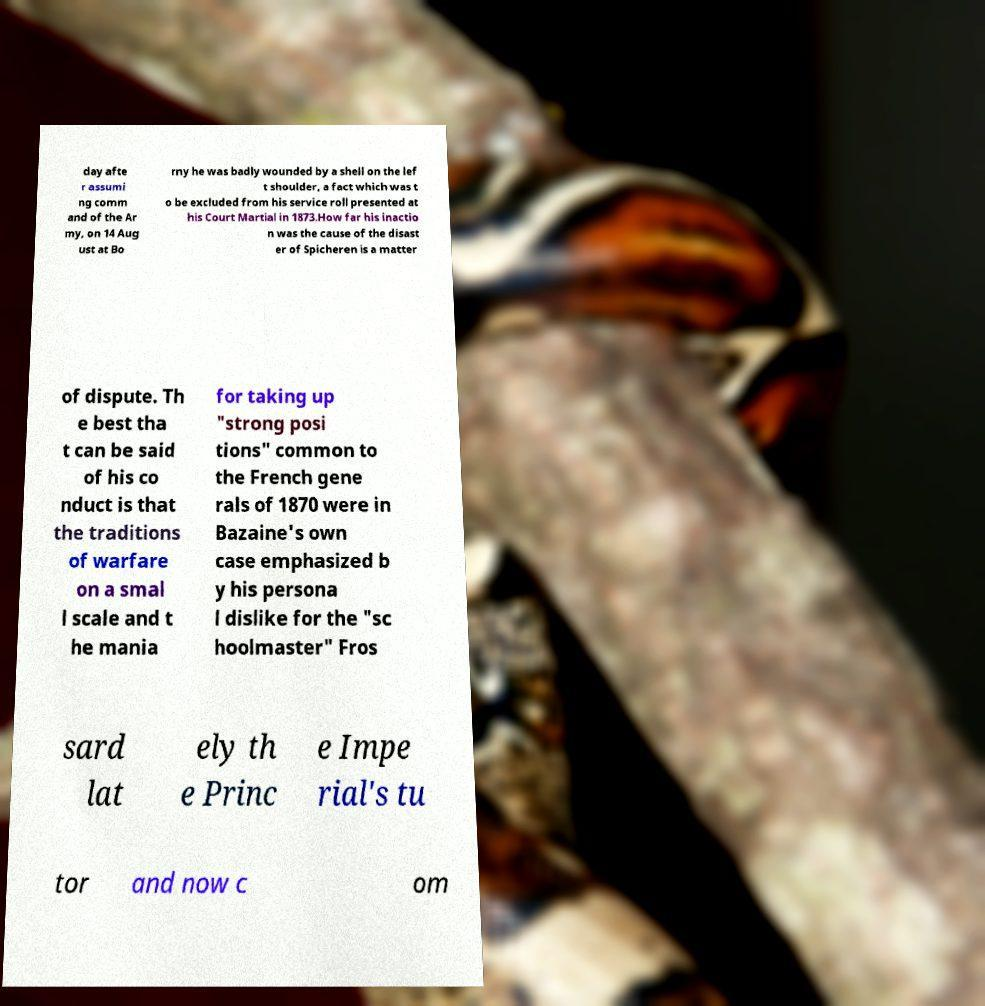Can you read and provide the text displayed in the image?This photo seems to have some interesting text. Can you extract and type it out for me? day afte r assumi ng comm and of the Ar my, on 14 Aug ust at Bo rny he was badly wounded by a shell on the lef t shoulder, a fact which was t o be excluded from his service roll presented at his Court Martial in 1873.How far his inactio n was the cause of the disast er of Spicheren is a matter of dispute. Th e best tha t can be said of his co nduct is that the traditions of warfare on a smal l scale and t he mania for taking up "strong posi tions" common to the French gene rals of 1870 were in Bazaine's own case emphasized b y his persona l dislike for the "sc hoolmaster" Fros sard lat ely th e Princ e Impe rial's tu tor and now c om 